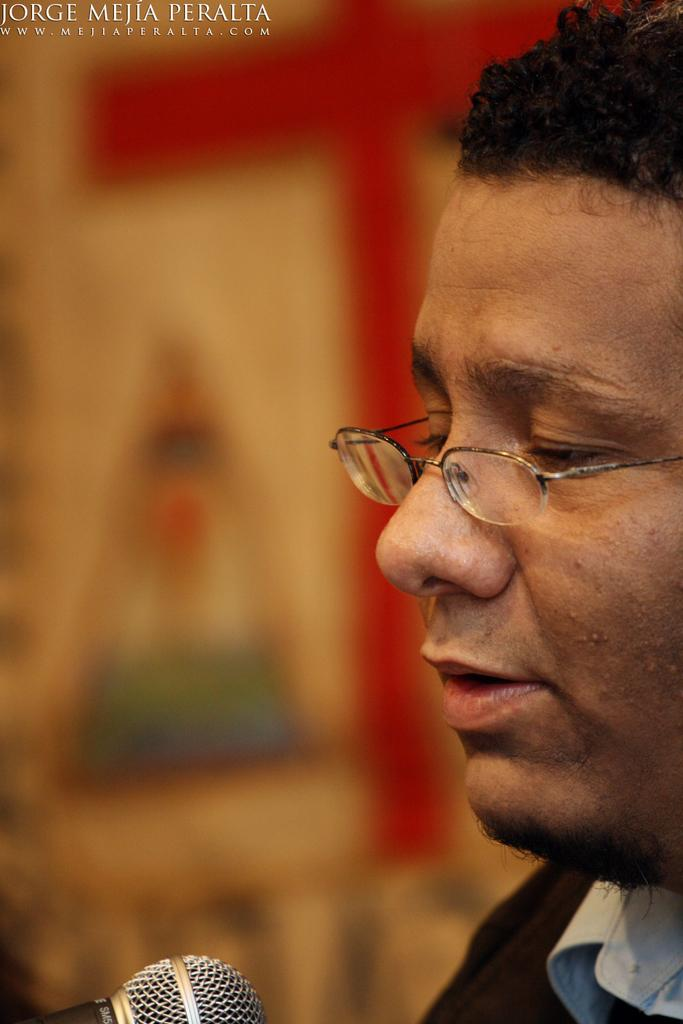What is the main subject in the foreground of the image? There is a man's face in the foreground of the image. On which side of the image is the man's face located? The man's face is on the right side of the image. What object is in front of the man's face? There is a microphone in front of the man. How would you describe the background of the image? The background of the image is blurred. What sense does the man's mother use to communicate with him in the image? There is no indication of the man's mother or any communication in the image. 